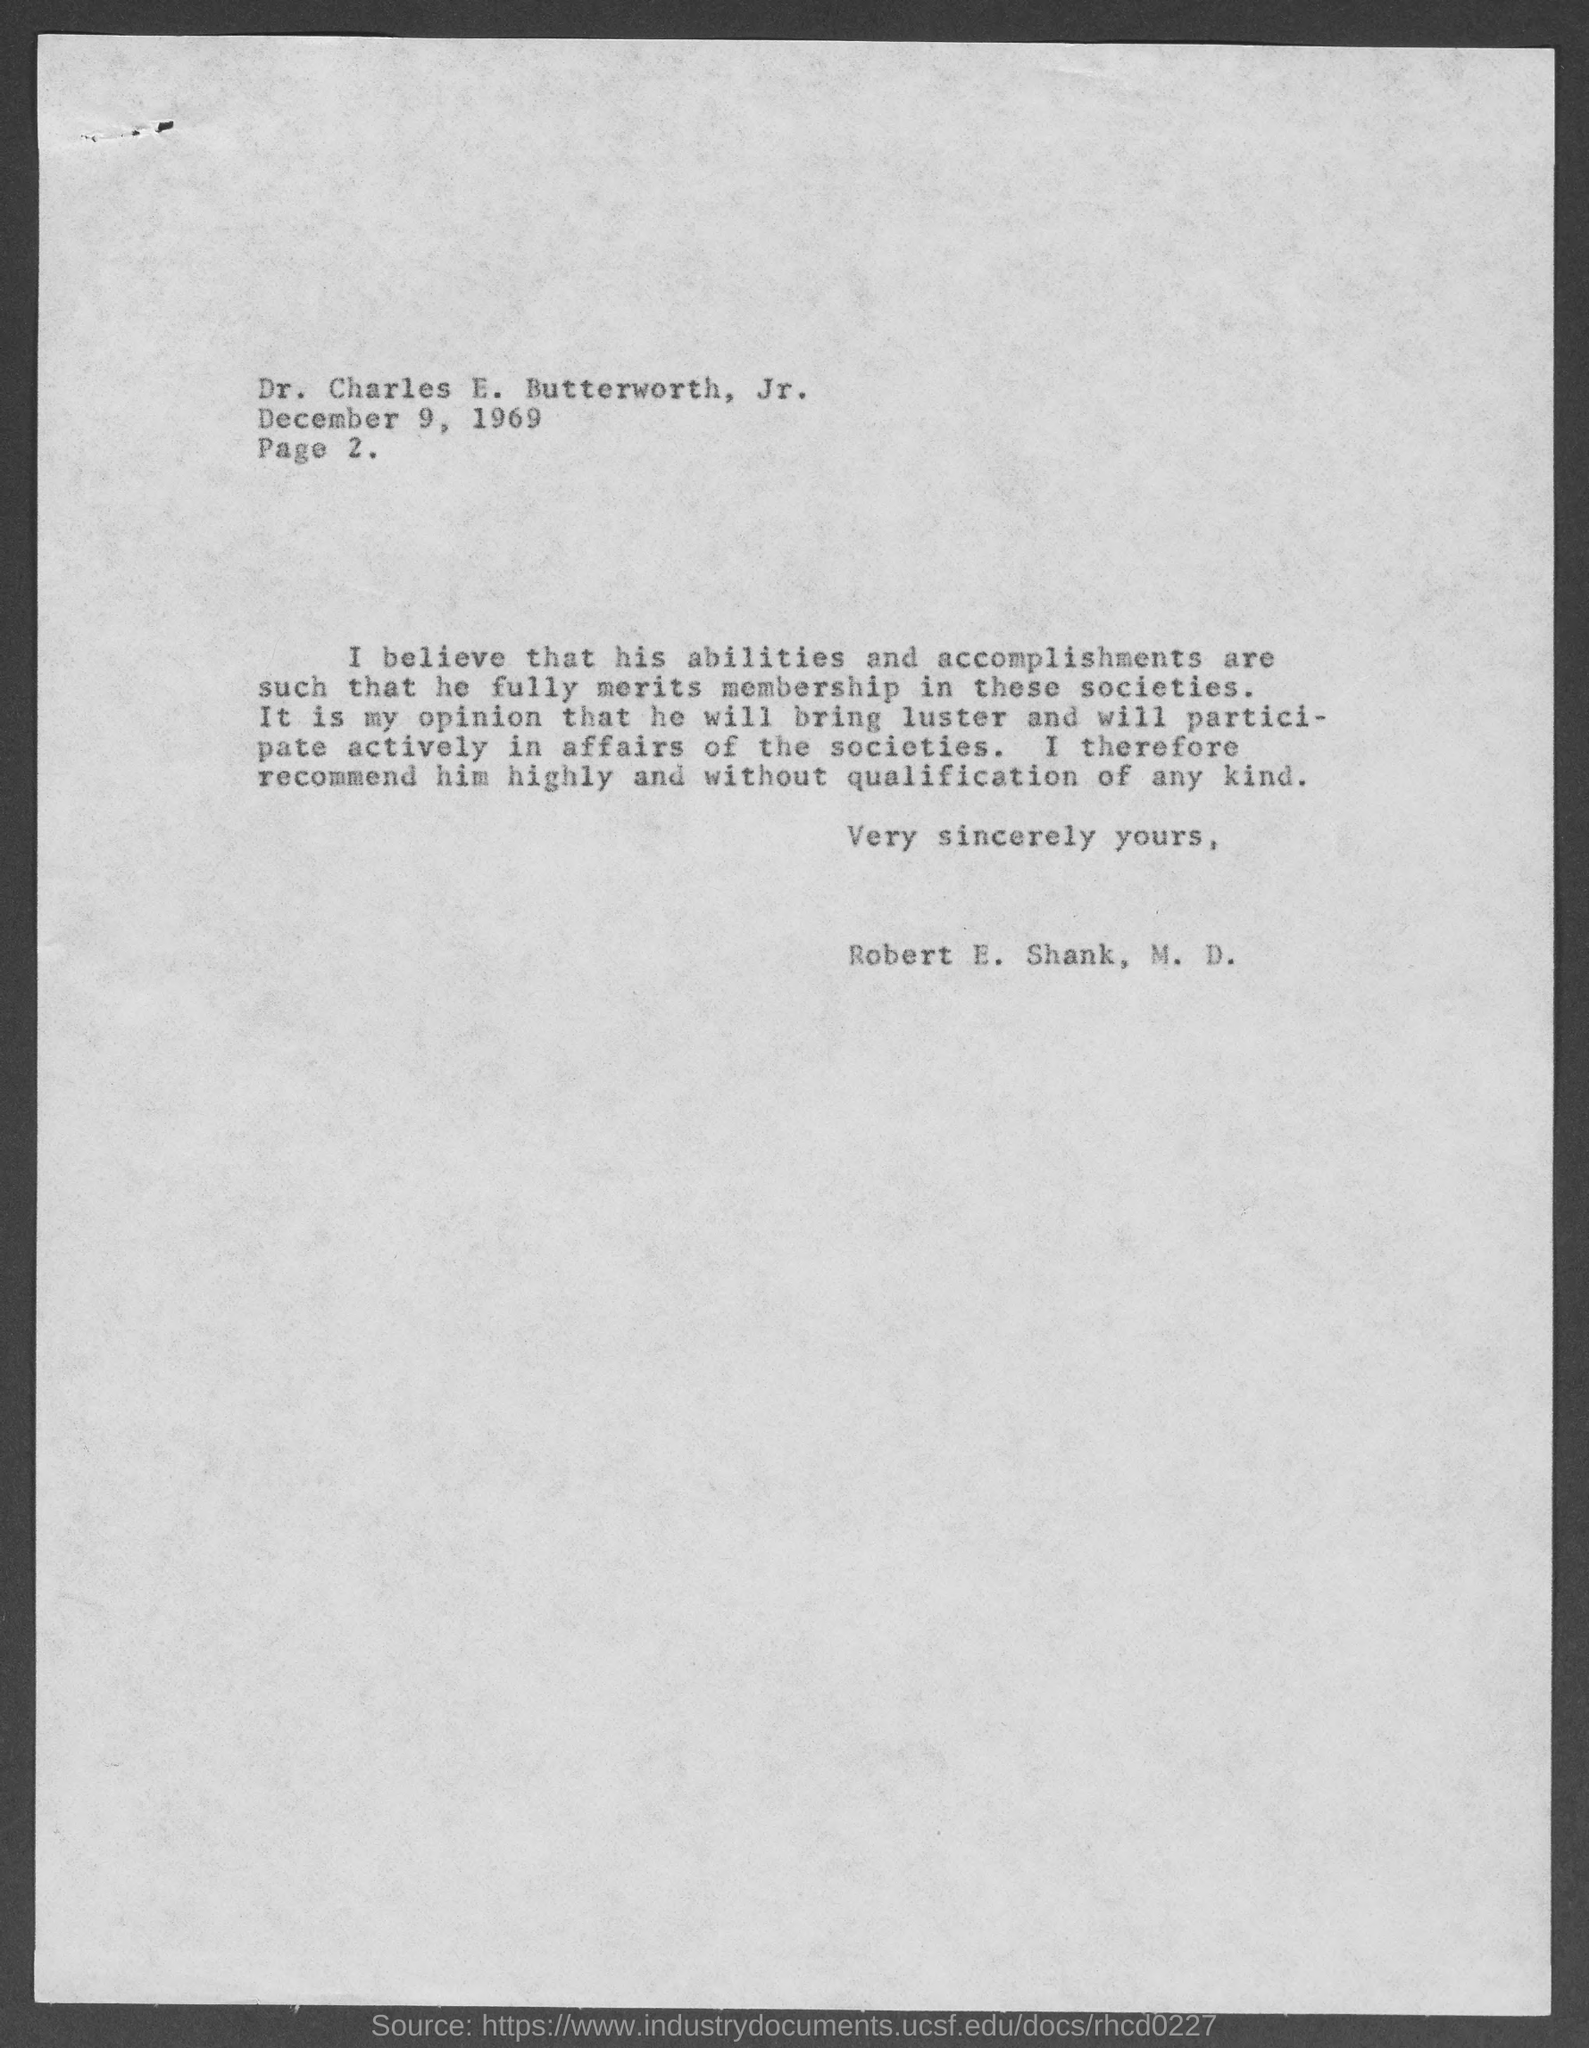Give some essential details in this illustration. The page number is 2, ranging from 2 to... This letter is addressed to Dr. Charles E. Butterworth, Jr. The letter is dated on December 9, 1969. 